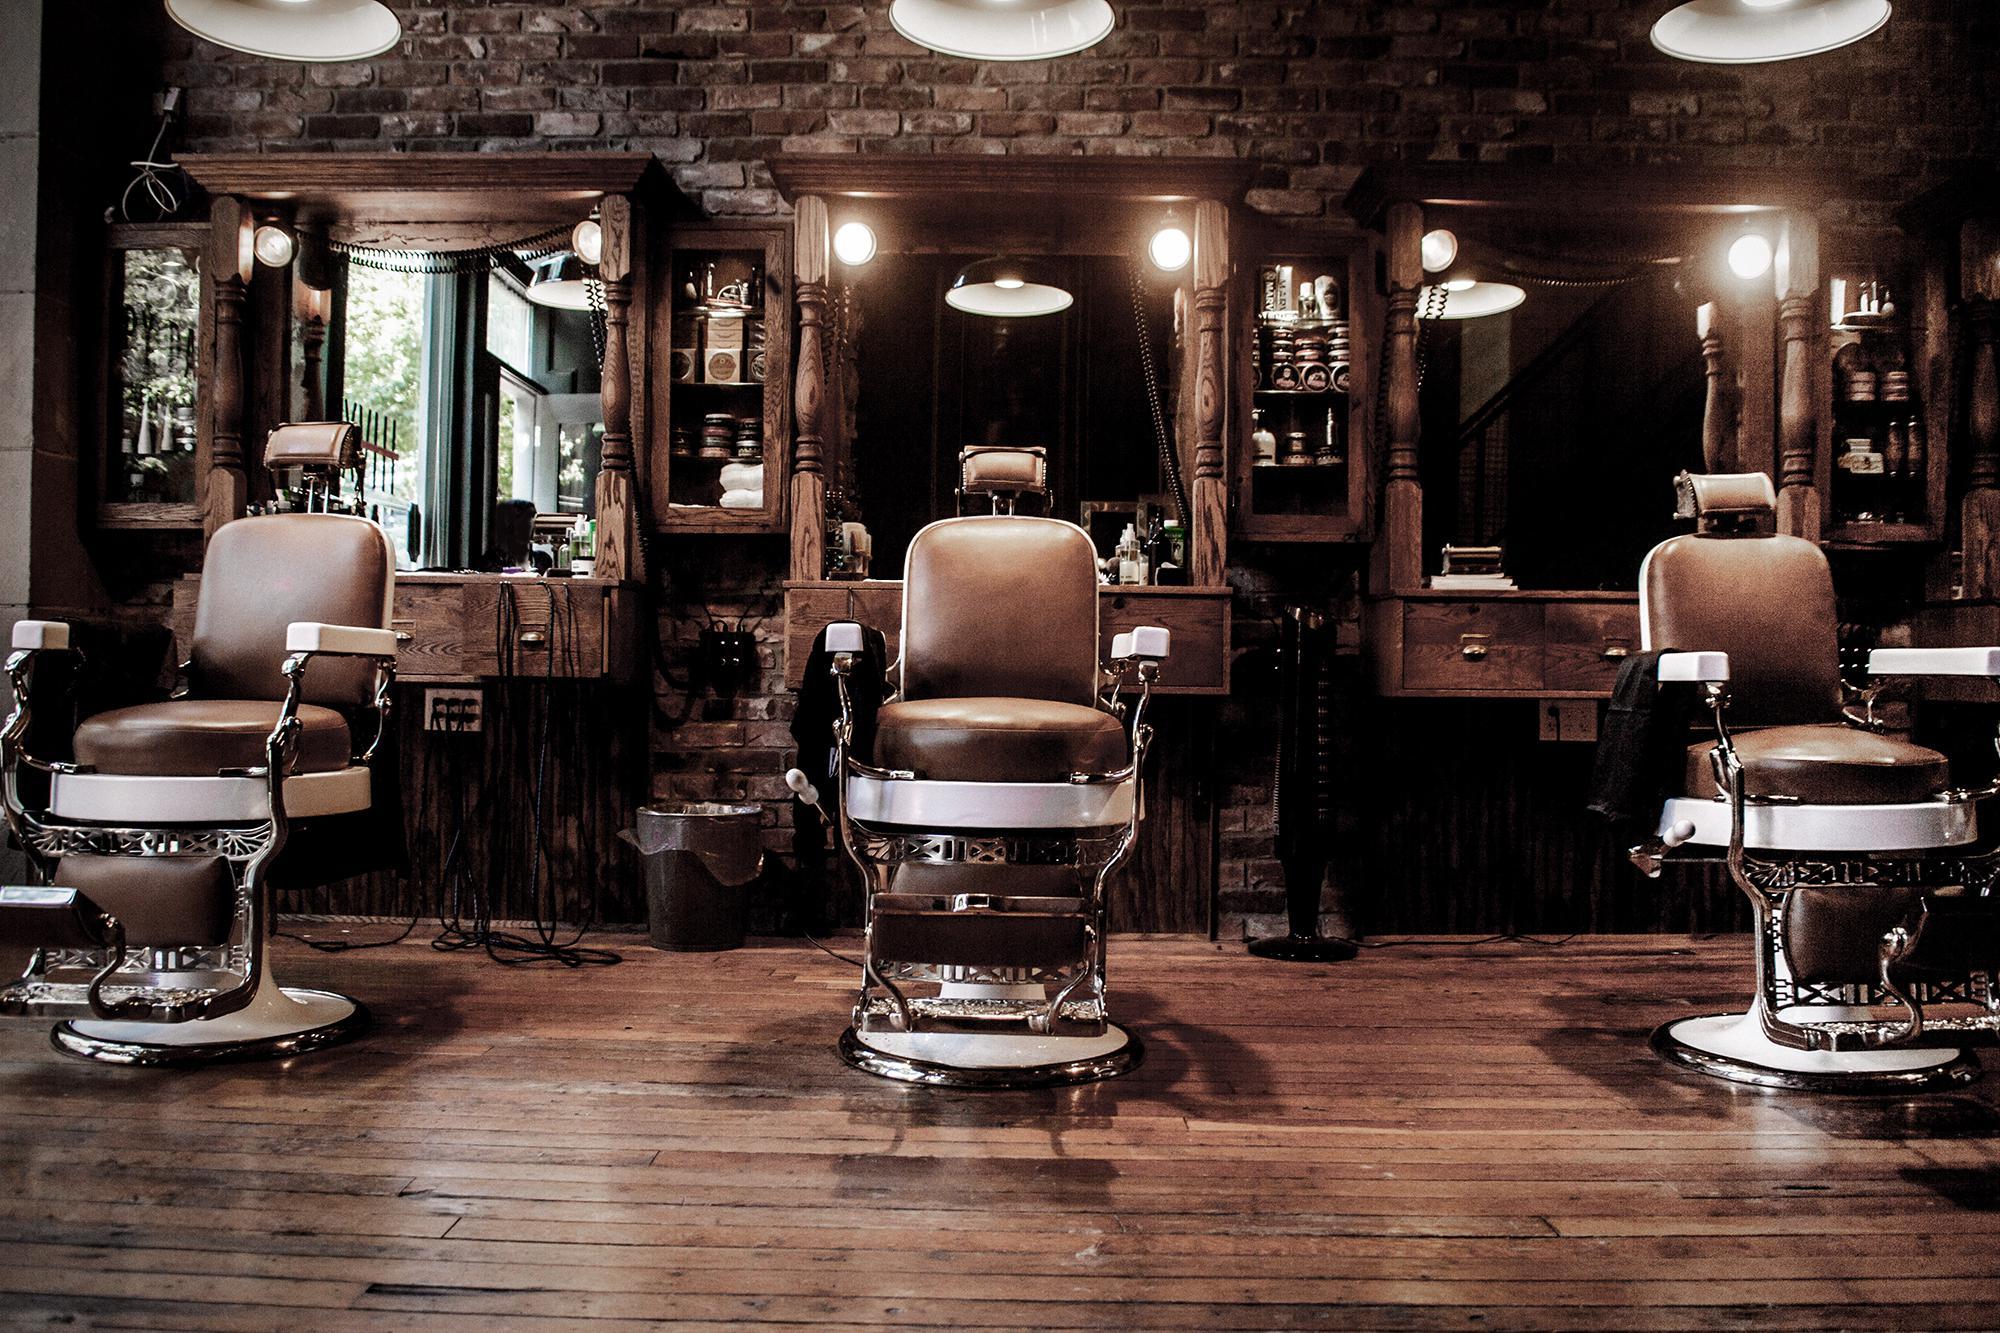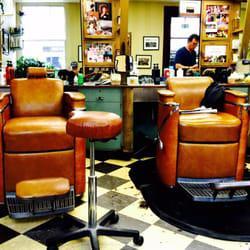The first image is the image on the left, the second image is the image on the right. For the images displayed, is the sentence "In one of the images there is a checkered floor and in the other image there is a wooden floor." factually correct? Answer yes or no. Yes. The first image is the image on the left, the second image is the image on the right. Given the left and right images, does the statement "There are people in one image but not in the other image." hold true? Answer yes or no. Yes. 